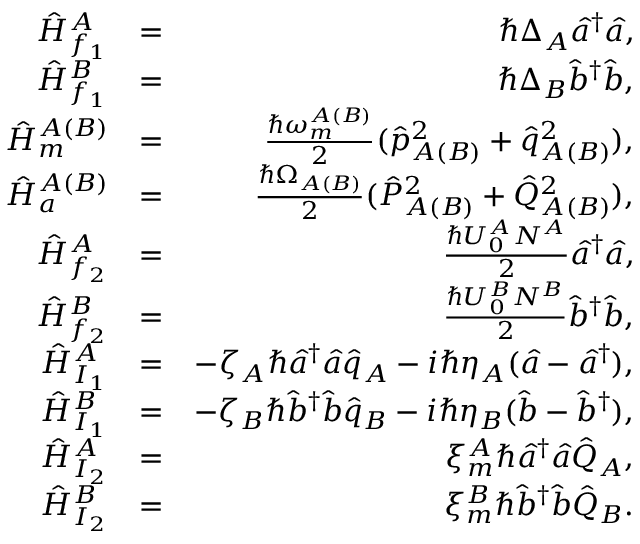Convert formula to latex. <formula><loc_0><loc_0><loc_500><loc_500>\begin{array} { r l r } { \hat { H } _ { f _ { 1 } } ^ { A } } & { = } & { \hbar { \Delta } _ { A } \hat { a } ^ { \dagger } \hat { a } , } \\ { \hat { H } _ { f _ { 1 } } ^ { B } } & { = } & { \hbar { \Delta } _ { B } \hat { b } ^ { \dagger } \hat { b } , } \\ { \hat { H } _ { m } ^ { A ( B ) } } & { = } & { \frac { \hbar { \omega } _ { m } ^ { A ( B ) } } { 2 } ( \hat { p } _ { A ( B ) } ^ { 2 } + \hat { q } _ { A ( B ) } ^ { 2 } ) , } \\ { \hat { H } _ { a } ^ { A ( B ) } } & { = } & { \frac { \hbar { \Omega } _ { A ( B ) } } { 2 } ( \hat { P } _ { A ( B ) } ^ { 2 } + \hat { Q } _ { A ( B ) } ^ { 2 } ) , } \\ { \hat { H } _ { f _ { 2 } } ^ { A } } & { = } & { \frac { \hbar { U } _ { 0 } ^ { A } N ^ { A } } { 2 } \hat { a } ^ { \dagger } \hat { a } , } \\ { \hat { H } _ { f _ { 2 } } ^ { B } } & { = } & { \frac { \hbar { U } _ { 0 } ^ { B } N ^ { B } } { 2 } \hat { b } ^ { \dagger } \hat { b } , } \\ { \hat { H } _ { I _ { 1 } } ^ { A } } & { = } & { - \zeta _ { A } \hbar { \hat } { a } ^ { \dagger } \hat { a } \hat { q } _ { A } - i \hbar { \eta } _ { A } ( \hat { a } - \hat { a } ^ { \dagger } ) , } \\ { \hat { H } _ { I _ { 1 } } ^ { B } } & { = } & { - \zeta _ { B } \hbar { \hat } { b } ^ { \dagger } \hat { b } \hat { q } _ { B } - i \hbar { \eta } _ { B } ( \hat { b } - \hat { b } ^ { \dagger } ) , } \\ { \hat { H } _ { I _ { 2 } } ^ { A } } & { = } & { \xi _ { m } ^ { A } \hbar { \hat } { a } ^ { \dagger } \hat { a } \hat { Q } _ { A } , } \\ { \hat { H } _ { I _ { 2 } } ^ { B } } & { = } & { \xi _ { m } ^ { B } \hbar { \hat } { b } ^ { \dagger } \hat { b } \hat { Q } _ { B } . } \end{array}</formula> 